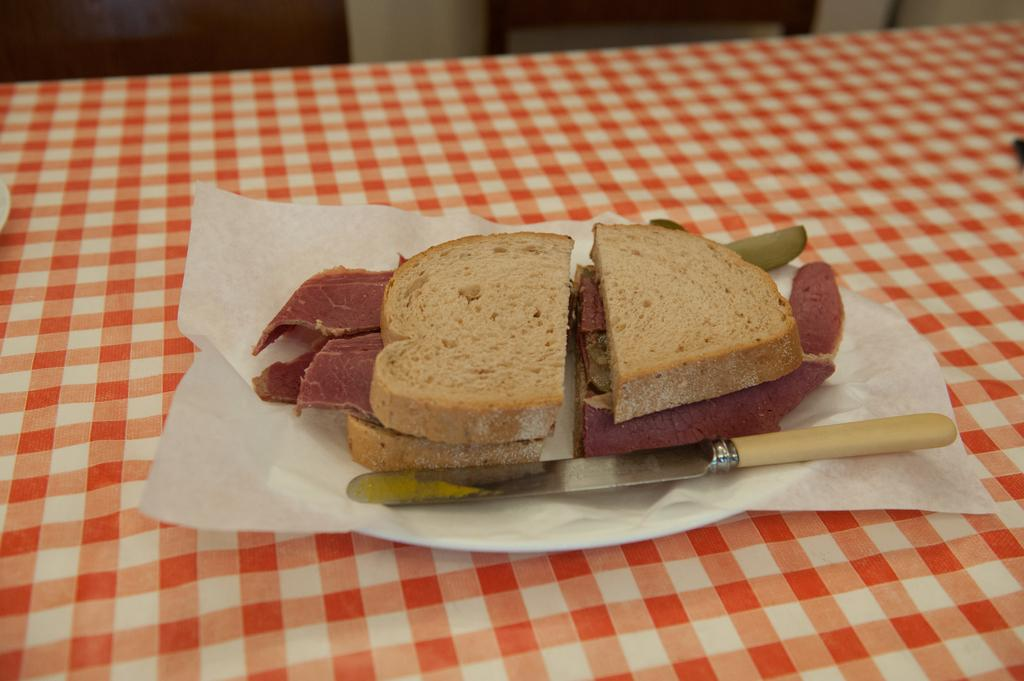What type of food is visible in the image? There is a sandwich in the image. What utensil is present in the image? There is a knife in the image. Where are the sandwich and knife located? The sandwich and knife are on a plate. What surface is the plate resting on? The plate is on a table. What type of material is covering the table? There is a cloth on the table. How many matches are on the table in the image? There are no matches present in the image. What type of animal can be seen grazing on the table in the image? There are no animals present in the image, let alone grazing on the table. 